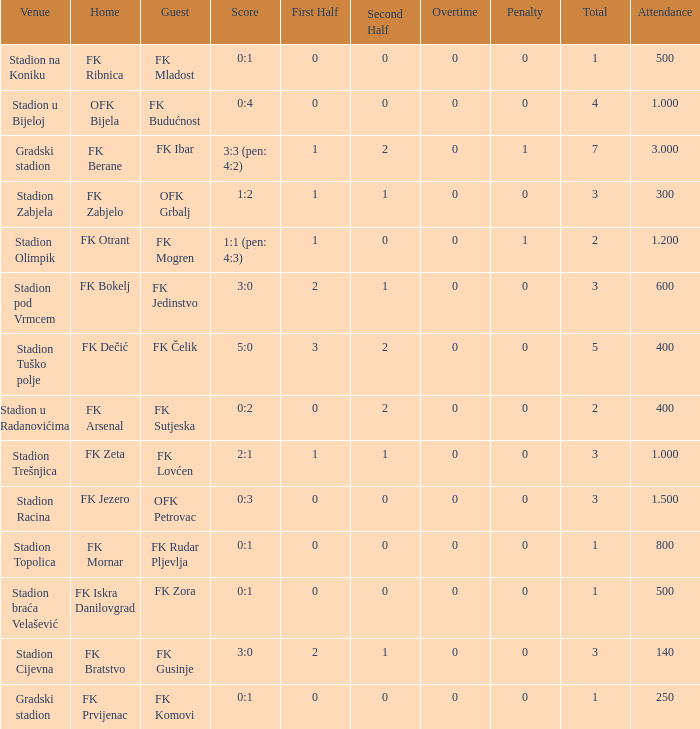What was the number of attendees at the game featuring fk mogren as the away team? 1.2. 